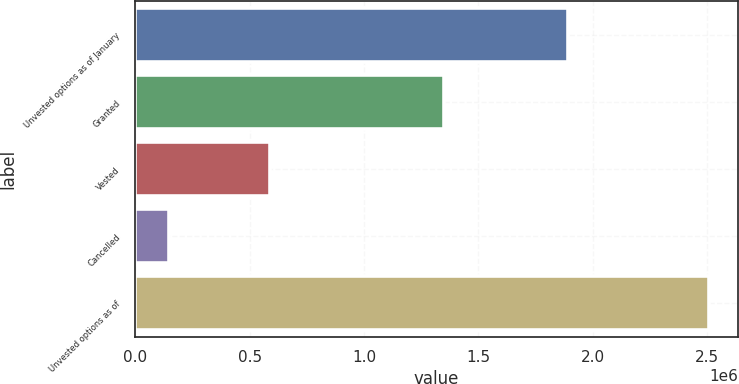<chart> <loc_0><loc_0><loc_500><loc_500><bar_chart><fcel>Unvested options as of January<fcel>Granted<fcel>Vested<fcel>Cancelled<fcel>Unvested options as of<nl><fcel>1.89319e+06<fcel>1.3495e+06<fcel>587813<fcel>146050<fcel>2.50882e+06<nl></chart> 